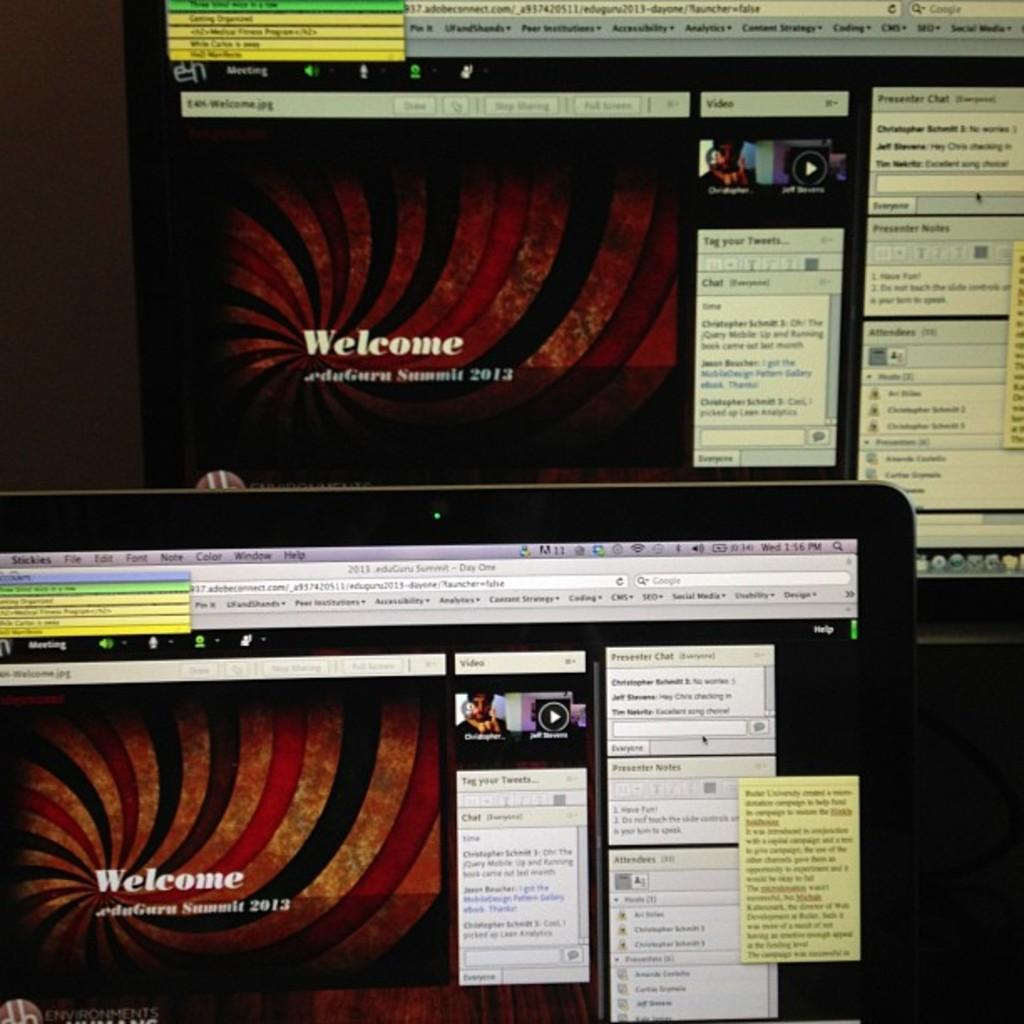Provide a one-sentence caption for the provided image. Two computer monitors with a red striped slide on them that says Welcome. 